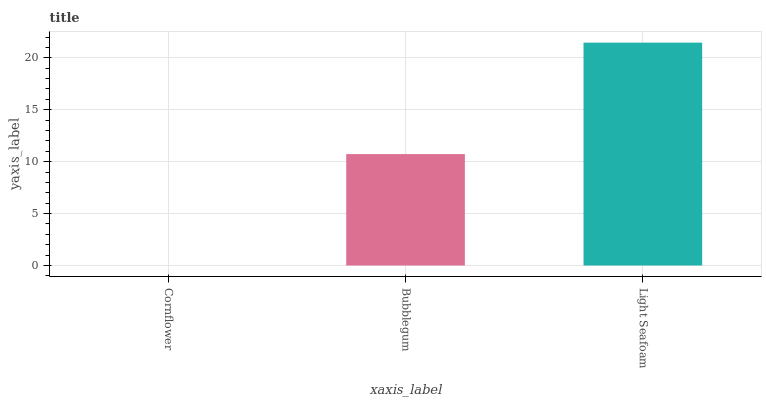Is Bubblegum the minimum?
Answer yes or no. No. Is Bubblegum the maximum?
Answer yes or no. No. Is Bubblegum greater than Cornflower?
Answer yes or no. Yes. Is Cornflower less than Bubblegum?
Answer yes or no. Yes. Is Cornflower greater than Bubblegum?
Answer yes or no. No. Is Bubblegum less than Cornflower?
Answer yes or no. No. Is Bubblegum the high median?
Answer yes or no. Yes. Is Bubblegum the low median?
Answer yes or no. Yes. Is Light Seafoam the high median?
Answer yes or no. No. Is Cornflower the low median?
Answer yes or no. No. 